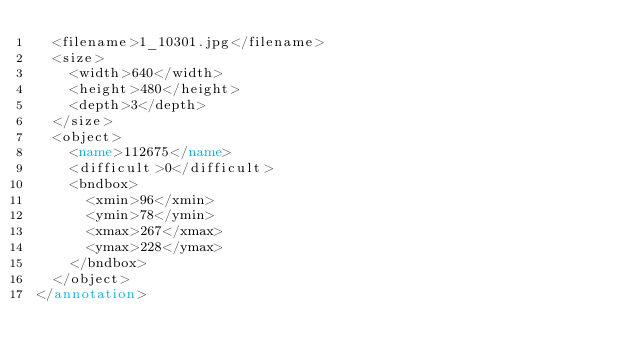Convert code to text. <code><loc_0><loc_0><loc_500><loc_500><_XML_>  <filename>1_10301.jpg</filename>
  <size>
    <width>640</width>
    <height>480</height>
    <depth>3</depth>
  </size>
  <object>
    <name>112675</name>
    <difficult>0</difficult>
    <bndbox>
      <xmin>96</xmin>
      <ymin>78</ymin>
      <xmax>267</xmax>
      <ymax>228</ymax>
    </bndbox>
  </object>
</annotation></code> 